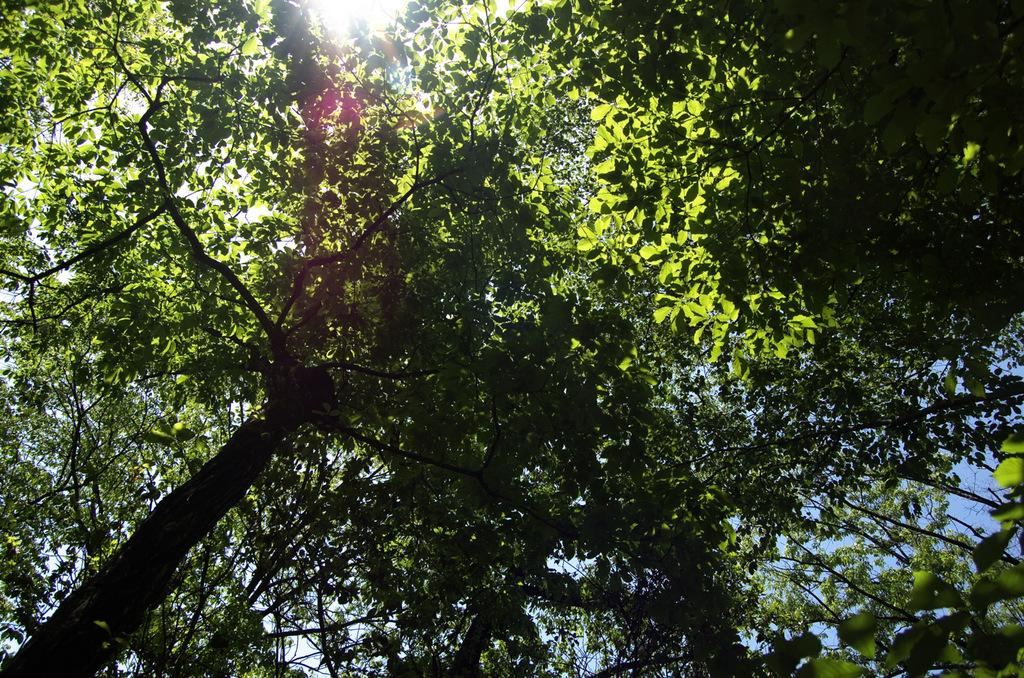What is located in the foreground of the image? There are trees in the foreground of the image. What can be seen at the top of the image? The rays of the sun are visible at the top of the image. How long does it take for the toothbrush to wash the trees in the image? There is no toothbrush present in the image, and trees cannot be washed. 